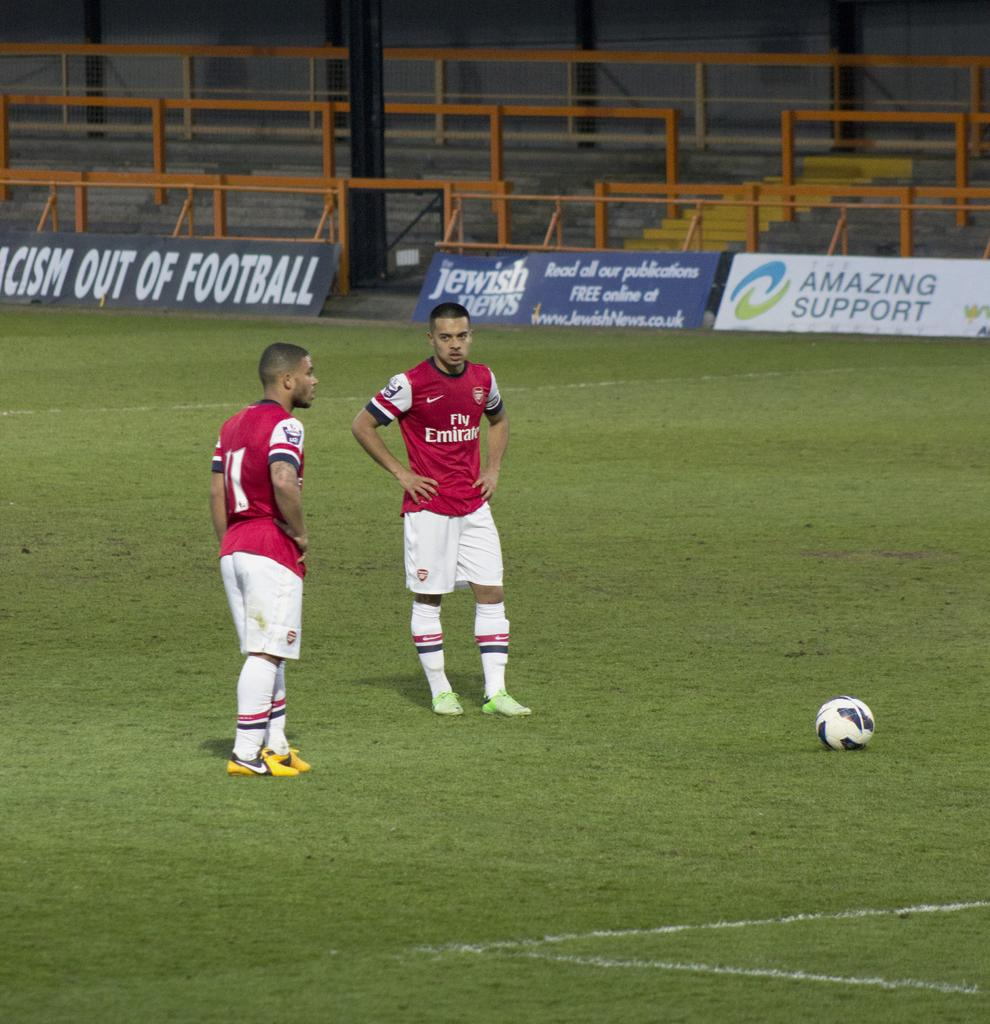How many people are present in the image? There are two men standing in the image. What is on the ground near the men? There is a ball on the ground in the image. What can be seen in the background of the image? There are banners, steps, and a fence in the background of the image. What scent can be detected coming from the men in the image? There is no information about the scent of the men in the image, so it cannot be determined. 